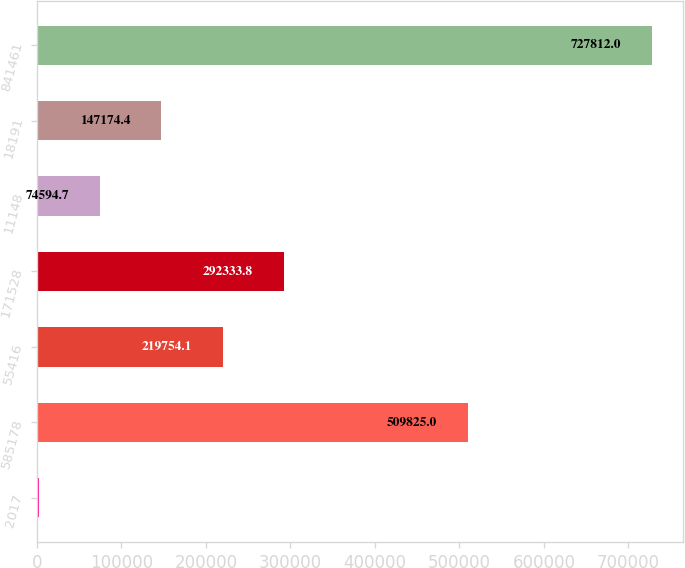<chart> <loc_0><loc_0><loc_500><loc_500><bar_chart><fcel>2017<fcel>585178<fcel>55416<fcel>171528<fcel>11148<fcel>18191<fcel>841461<nl><fcel>2015<fcel>509825<fcel>219754<fcel>292334<fcel>74594.7<fcel>147174<fcel>727812<nl></chart> 